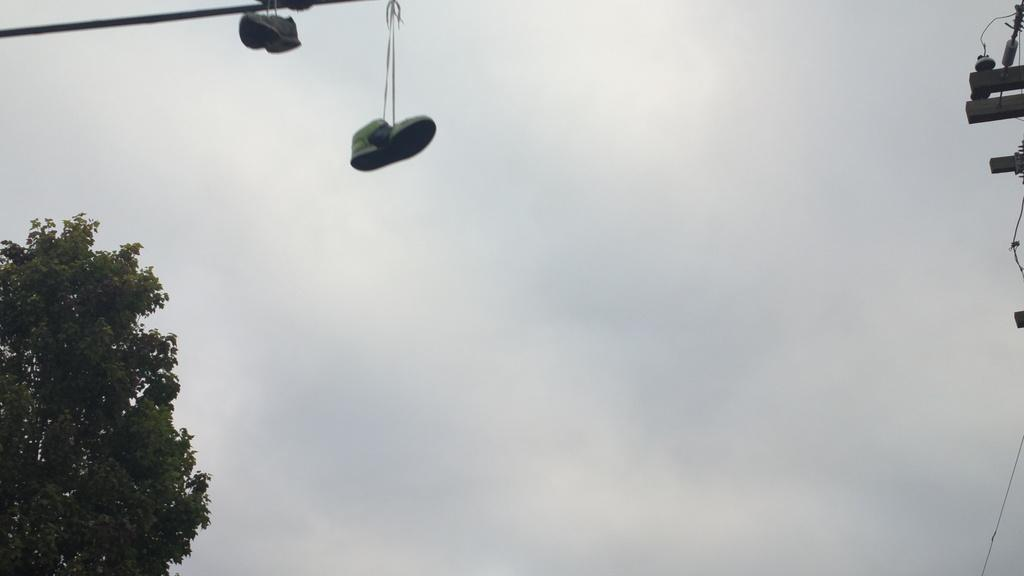What can be seen at the top of the image? The sky is visible in the image, and there is a wire at the top of the image. What is located on the left side of the image? There is a tree on the left side of the image. What is present in the top right of the image? There is a pole in the top right of the image. What is hanging from the wire in the image? Shoes are hanging from the wire. What is the source of blood in the image? There is no blood present in the image. How does the wealth of the people in the image manifest itself? The image does not provide any information about the wealth of the people. 